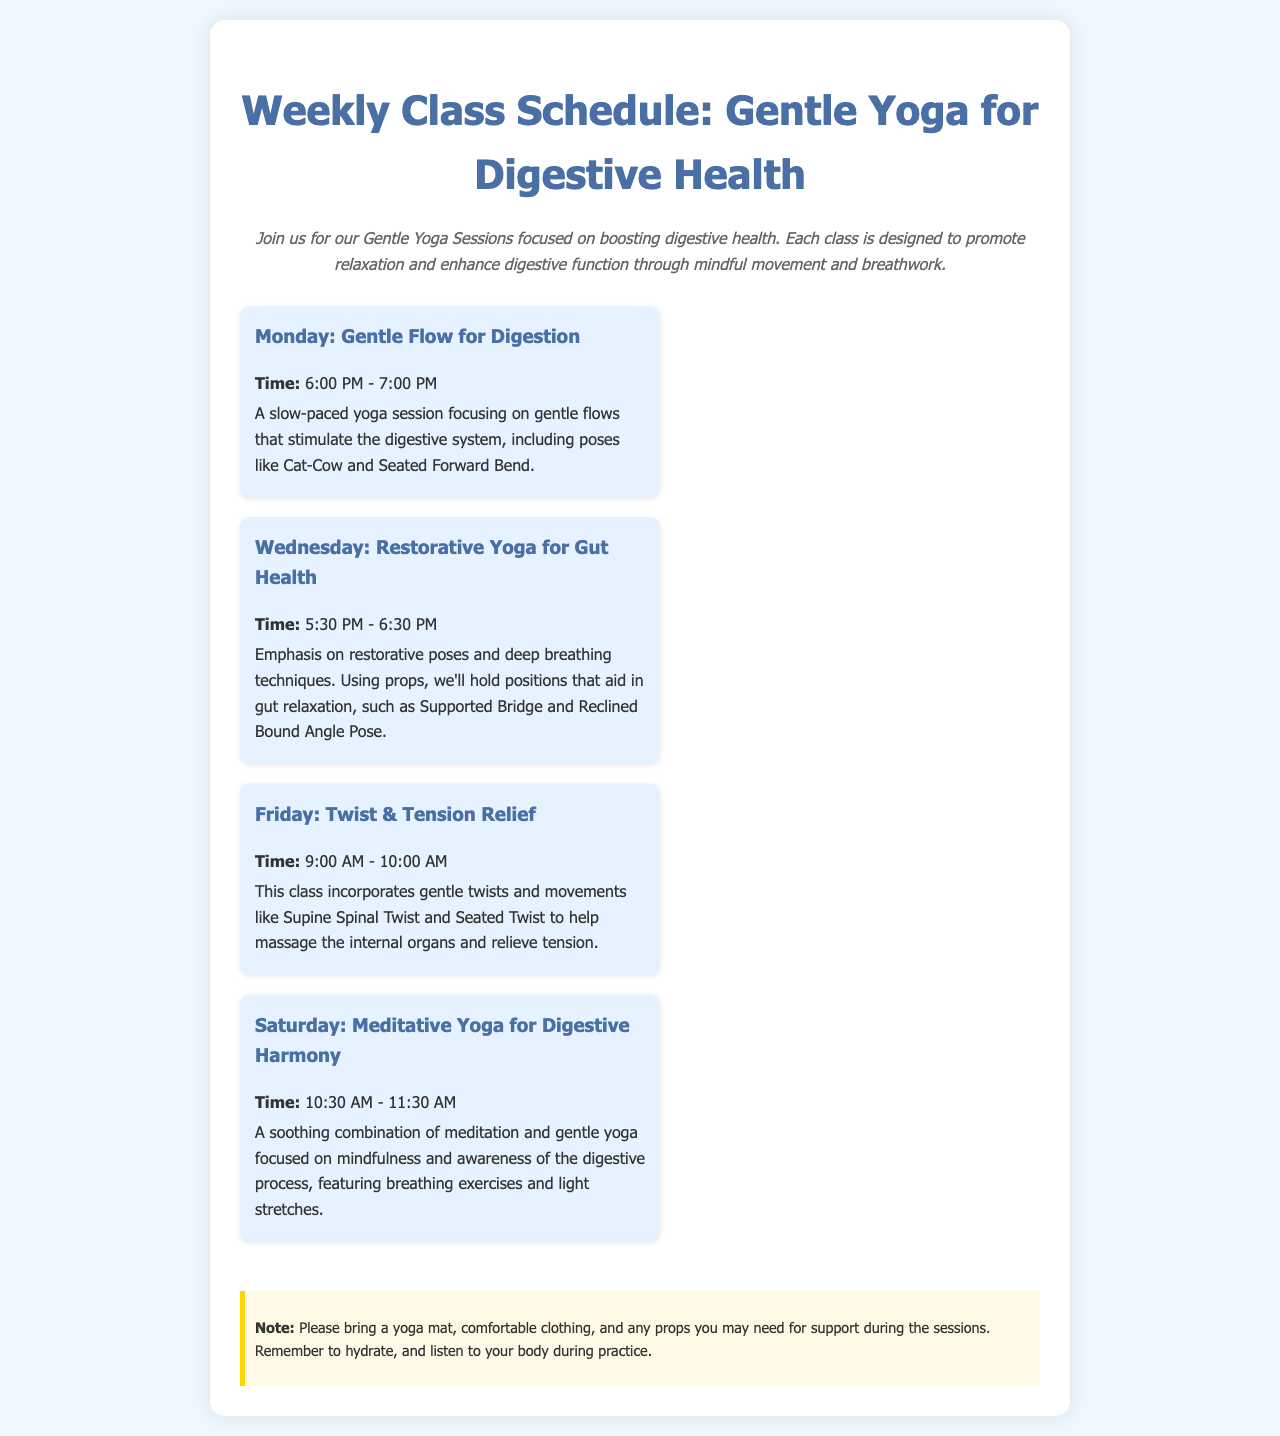What day is the Gentle Flow for Digestion class? The Gentle Flow for Digestion class is scheduled for Monday.
Answer: Monday What time does the Restorative Yoga for Gut Health class start? The Restorative Yoga for Gut Health class starts at 5:30 PM.
Answer: 5:30 PM Which pose is emphasized in the Friday class? The Friday class emphasizes gentle twists, including the Supine Spinal Twist.
Answer: Supine Spinal Twist How long does the Saturday class last? The Saturday class lasts for 1 hour, from 10:30 AM to 11:30 AM.
Answer: 1 hour What should participants bring to the sessions? Participants should bring a yoga mat and comfortable clothing.
Answer: A yoga mat and comfortable clothing What is the focus of the Wednesday class? The focus of the Wednesday class is on restorative poses and deep breathing techniques.
Answer: Restorative poses and deep breathing techniques What type of yoga is practiced on Monday? The type of yoga practiced on Monday is Gentle Flow.
Answer: Gentle Flow Which class is designed for both meditation and yoga? The Saturday class is designed for both meditation and yoga.
Answer: Saturday How many classes are offered in total? There are four classes offered in total throughout the week.
Answer: Four 